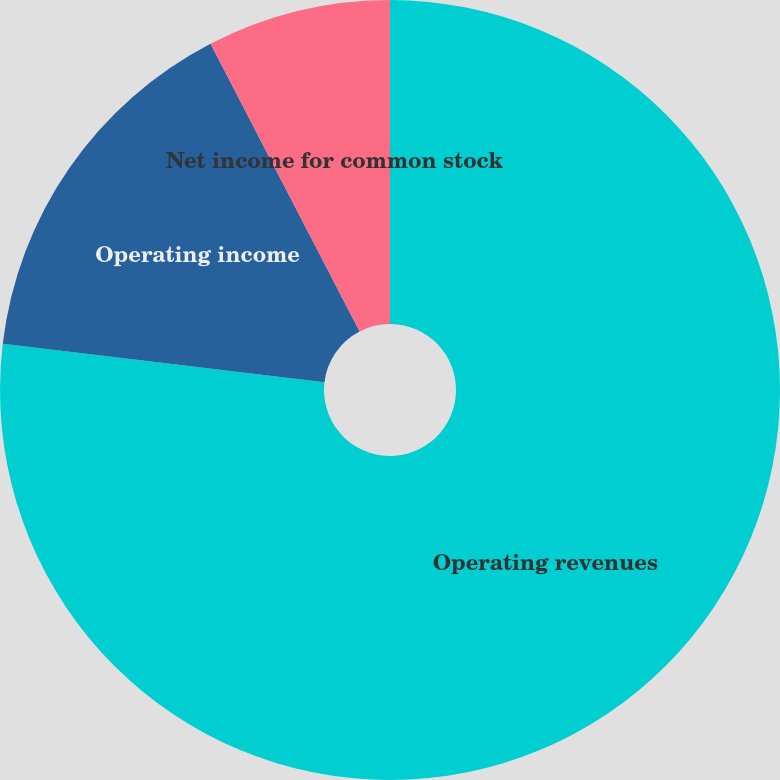<chart> <loc_0><loc_0><loc_500><loc_500><pie_chart><fcel>Operating revenues<fcel>Operating income<fcel>Net income for common stock<nl><fcel>76.89%<fcel>15.5%<fcel>7.61%<nl></chart> 